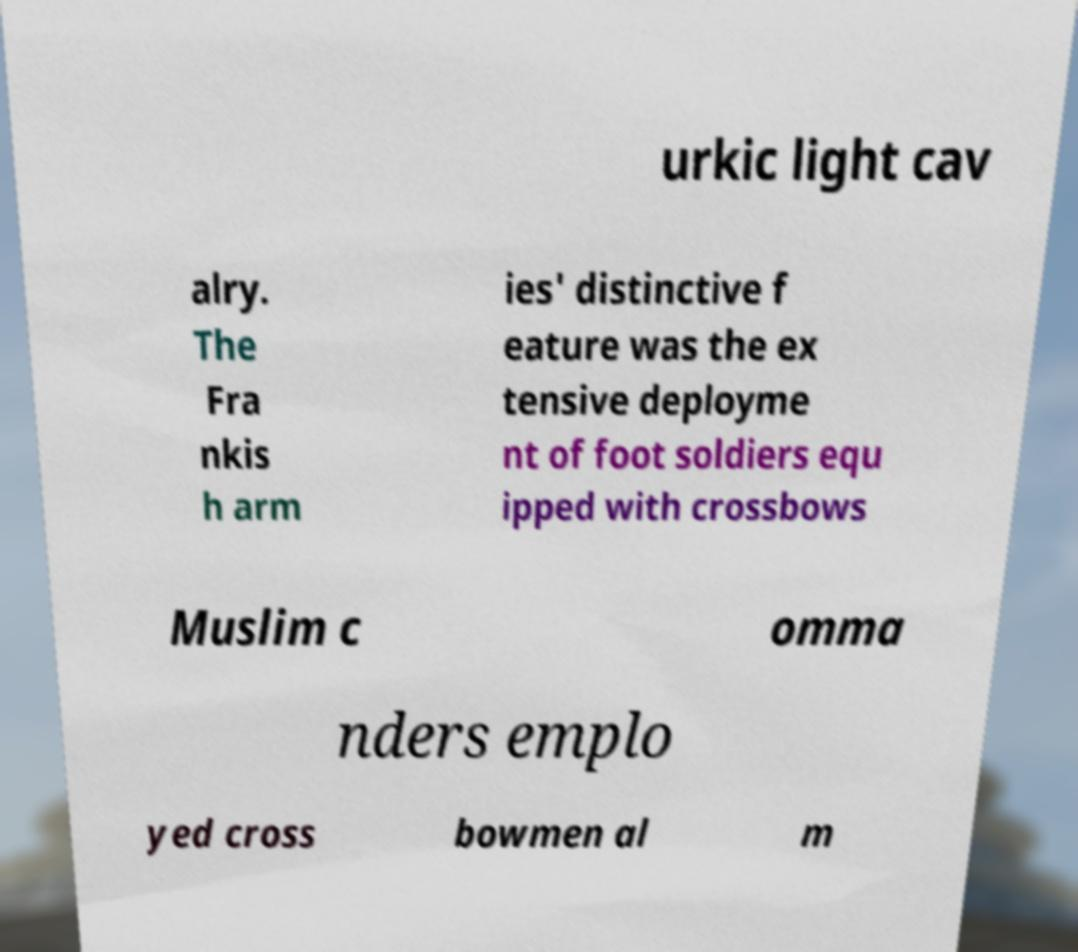There's text embedded in this image that I need extracted. Can you transcribe it verbatim? urkic light cav alry. The Fra nkis h arm ies' distinctive f eature was the ex tensive deployme nt of foot soldiers equ ipped with crossbows Muslim c omma nders emplo yed cross bowmen al m 